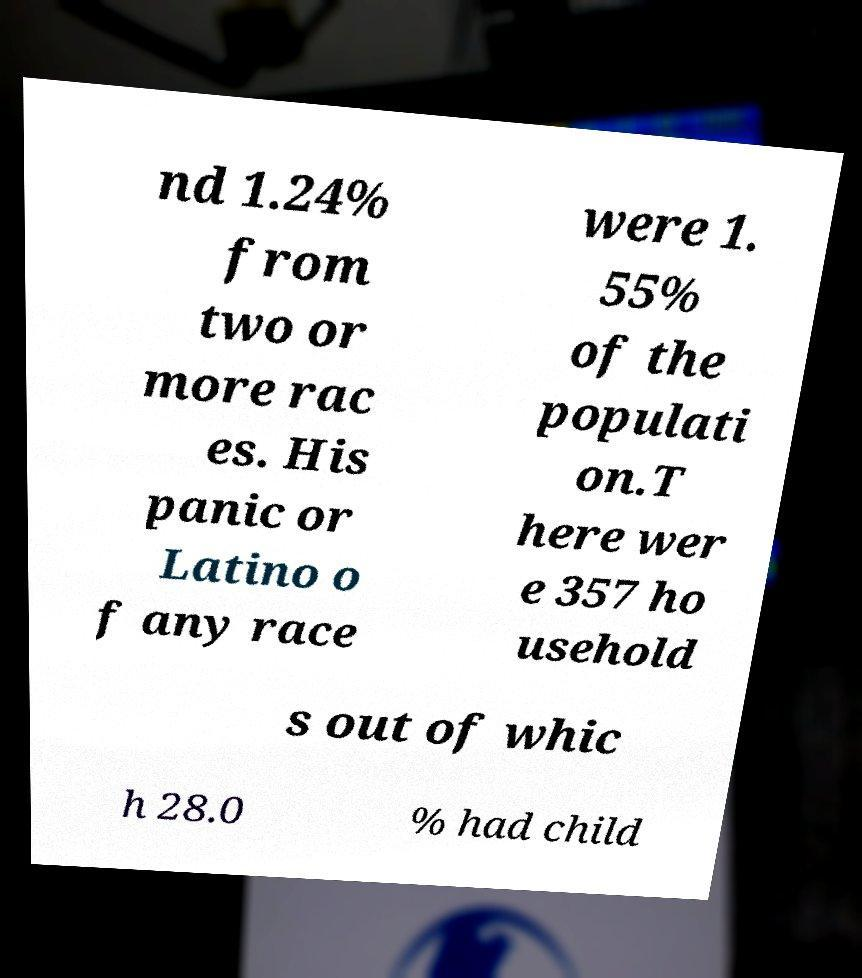For documentation purposes, I need the text within this image transcribed. Could you provide that? nd 1.24% from two or more rac es. His panic or Latino o f any race were 1. 55% of the populati on.T here wer e 357 ho usehold s out of whic h 28.0 % had child 